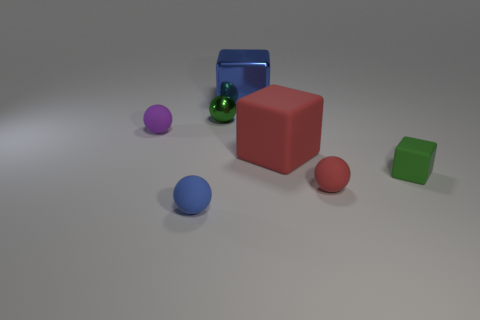There is a sphere that is to the right of the large red object; are there any small matte things that are to the left of it?
Make the answer very short. Yes. What number of other objects are there of the same shape as the green metallic thing?
Make the answer very short. 3. Do the small metal object and the blue rubber object have the same shape?
Ensure brevity in your answer.  Yes. What color is the small rubber object that is both right of the large red matte object and to the left of the tiny rubber block?
Your answer should be very brief. Red. What is the size of the object that is the same color as the large shiny block?
Your answer should be compact. Small. How many tiny objects are purple matte cubes or blue rubber balls?
Provide a short and direct response. 1. What is the material of the object in front of the tiny rubber sphere right of the tiny matte object in front of the small red ball?
Give a very brief answer. Rubber. How many matte objects are large blue blocks or green cylinders?
Give a very brief answer. 0. How many purple things are tiny cubes or rubber spheres?
Ensure brevity in your answer.  1. Is the color of the big thing behind the tiny purple rubber sphere the same as the tiny metal object?
Provide a short and direct response. No. 